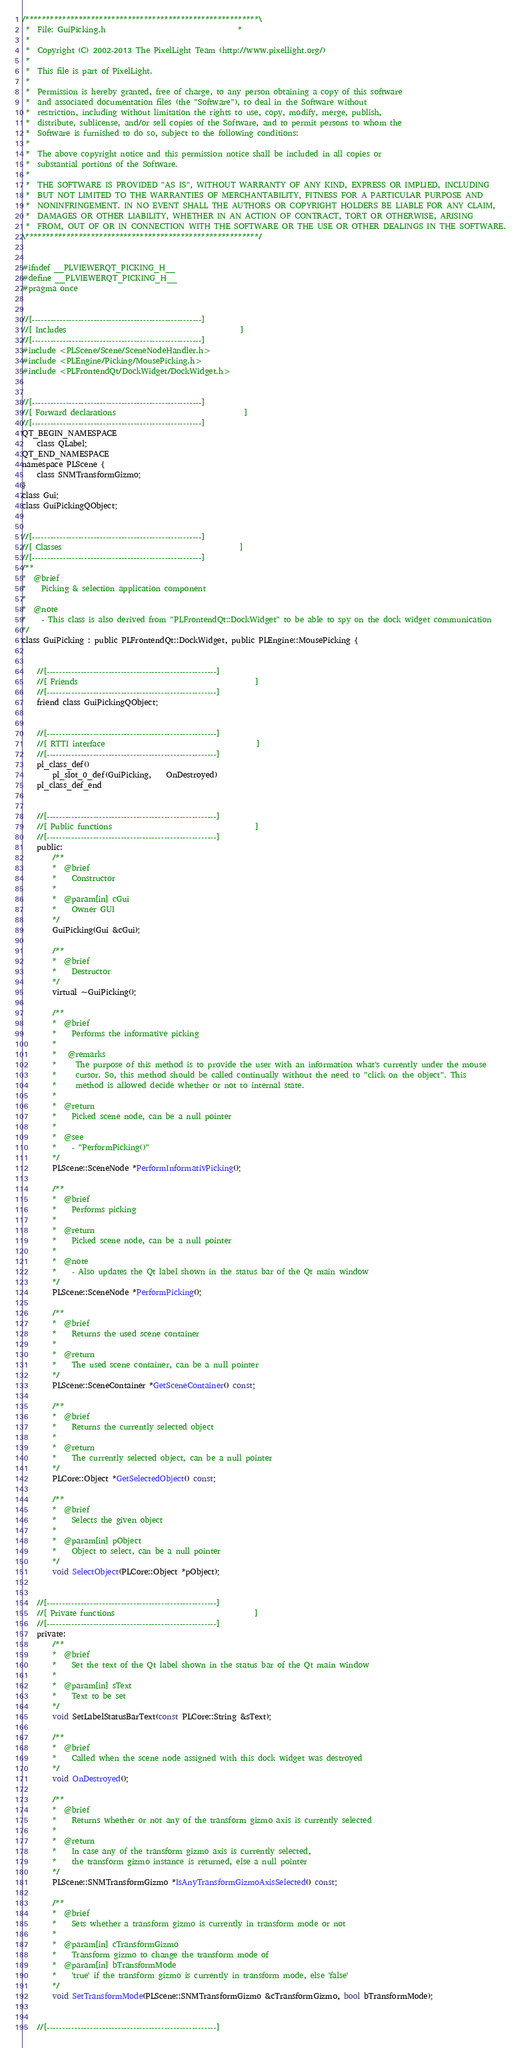<code> <loc_0><loc_0><loc_500><loc_500><_C_>/*********************************************************\
 *  File: GuiPicking.h                                   *
 *
 *  Copyright (C) 2002-2013 The PixelLight Team (http://www.pixellight.org/)
 *
 *  This file is part of PixelLight.
 *
 *  Permission is hereby granted, free of charge, to any person obtaining a copy of this software
 *  and associated documentation files (the "Software"), to deal in the Software without
 *  restriction, including without limitation the rights to use, copy, modify, merge, publish,
 *  distribute, sublicense, and/or sell copies of the Software, and to permit persons to whom the
 *  Software is furnished to do so, subject to the following conditions:
 *
 *  The above copyright notice and this permission notice shall be included in all copies or
 *  substantial portions of the Software.
 *
 *  THE SOFTWARE IS PROVIDED "AS IS", WITHOUT WARRANTY OF ANY KIND, EXPRESS OR IMPLIED, INCLUDING
 *  BUT NOT LIMITED TO THE WARRANTIES OF MERCHANTABILITY, FITNESS FOR A PARTICULAR PURPOSE AND
 *  NONINFRINGEMENT. IN NO EVENT SHALL THE AUTHORS OR COPYRIGHT HOLDERS BE LIABLE FOR ANY CLAIM,
 *  DAMAGES OR OTHER LIABILITY, WHETHER IN AN ACTION OF CONTRACT, TORT OR OTHERWISE, ARISING
 *  FROM, OUT OF OR IN CONNECTION WITH THE SOFTWARE OR THE USE OR OTHER DEALINGS IN THE SOFTWARE.
\*********************************************************/


#ifndef __PLVIEWERQT_PICKING_H__
#define __PLVIEWERQT_PICKING_H__
#pragma once


//[-------------------------------------------------------]
//[ Includes                                              ]
//[-------------------------------------------------------]
#include <PLScene/Scene/SceneNodeHandler.h>
#include <PLEngine/Picking/MousePicking.h>
#include <PLFrontendQt/DockWidget/DockWidget.h>


//[-------------------------------------------------------]
//[ Forward declarations                                  ]
//[-------------------------------------------------------]
QT_BEGIN_NAMESPACE
	class QLabel;
QT_END_NAMESPACE
namespace PLScene {
	class SNMTransformGizmo;
}
class Gui;
class GuiPickingQObject;


//[-------------------------------------------------------]
//[ Classes                                               ]
//[-------------------------------------------------------]
/**
*  @brief
*    Picking & selection application component
*
*  @note
*    - This class is also derived from "PLFrontendQt::DockWidget" to be able to spy on the dock widget communication
*/
class GuiPicking : public PLFrontendQt::DockWidget, public PLEngine::MousePicking {


	//[-------------------------------------------------------]
	//[ Friends                                               ]
	//[-------------------------------------------------------]
	friend class GuiPickingQObject;


	//[-------------------------------------------------------]
	//[ RTTI interface                                        ]
	//[-------------------------------------------------------]
	pl_class_def()
		pl_slot_0_def(GuiPicking,	OnDestroyed)
	pl_class_def_end


	//[-------------------------------------------------------]
	//[ Public functions                                      ]
	//[-------------------------------------------------------]
	public:
		/**
		*  @brief
		*    Constructor
		*
		*  @param[in] cGui
		*    Owner GUI
		*/
		GuiPicking(Gui &cGui);

		/**
		*  @brief
		*    Destructor
		*/
		virtual ~GuiPicking();

		/**
		*  @brief
		*    Performs the informative picking
		*
		*   @remarks
		*     The purpose of this method is to provide the user with an information what's currently under the mouse
		*     cursor. So, this method should be called continually without the need to "click on the object". This
		*     method is allowed decide whether or not to internal state.
		*
		*  @return
		*    Picked scene node, can be a null pointer
		*
		*  @see
		*    - "PerformPicking()"
		*/
		PLScene::SceneNode *PerformInformativPicking();

		/**
		*  @brief
		*    Performs picking
		*
		*  @return
		*    Picked scene node, can be a null pointer
		*
		*  @note
		*    - Also updates the Qt label shown in the status bar of the Qt main window
		*/
		PLScene::SceneNode *PerformPicking();

		/**
		*  @brief
		*    Returns the used scene container
		*
		*  @return
		*    The used scene container, can be a null pointer
		*/
		PLScene::SceneContainer *GetSceneContainer() const;

		/**
		*  @brief
		*    Returns the currently selected object
		*
		*  @return
		*    The currently selected object, can be a null pointer
		*/
		PLCore::Object *GetSelectedObject() const;

		/**
		*  @brief
		*    Selects the given object
		*
		*  @param[in] pObject
		*    Object to select, can be a null pointer
		*/
		void SelectObject(PLCore::Object *pObject);


	//[-------------------------------------------------------]
	//[ Private functions                                     ]
	//[-------------------------------------------------------]
	private:
		/**
		*  @brief
		*    Set the text of the Qt label shown in the status bar of the Qt main window
		*
		*  @param[in] sText
		*    Text to be set
		*/
		void SetLabelStatusBarText(const PLCore::String &sText);

		/**
		*  @brief
		*    Called when the scene node assigned with this dock widget was destroyed
		*/
		void OnDestroyed();

		/**
		*  @brief
		*    Returns whether or not any of the transform gizmo axis is currently selected
		*
		*  @return
		*    In case any of the transform gizmo axis is currently selected,
		*    the transform gizmo instance is returned, else a null pointer
		*/
		PLScene::SNMTransformGizmo *IsAnyTransformGizmoAxisSelected() const;

		/**
		*  @brief
		*    Sets whether a transform gizmo is currently in transform mode or not
		*
		*  @param[in] cTransformGizmo
		*    Transform gizmo to change the transform mode of
		*  @param[in] bTransformMode
		*    'true' if the transform gizmo is currently in transform mode, else 'false'
		*/
		void SetTransformMode(PLScene::SNMTransformGizmo &cTransformGizmo, bool bTransformMode);


	//[-------------------------------------------------------]</code> 